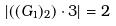<formula> <loc_0><loc_0><loc_500><loc_500>\left | ( ( G _ { 1 } ) _ { 2 } ) \cdot 3 \right | = 2</formula> 